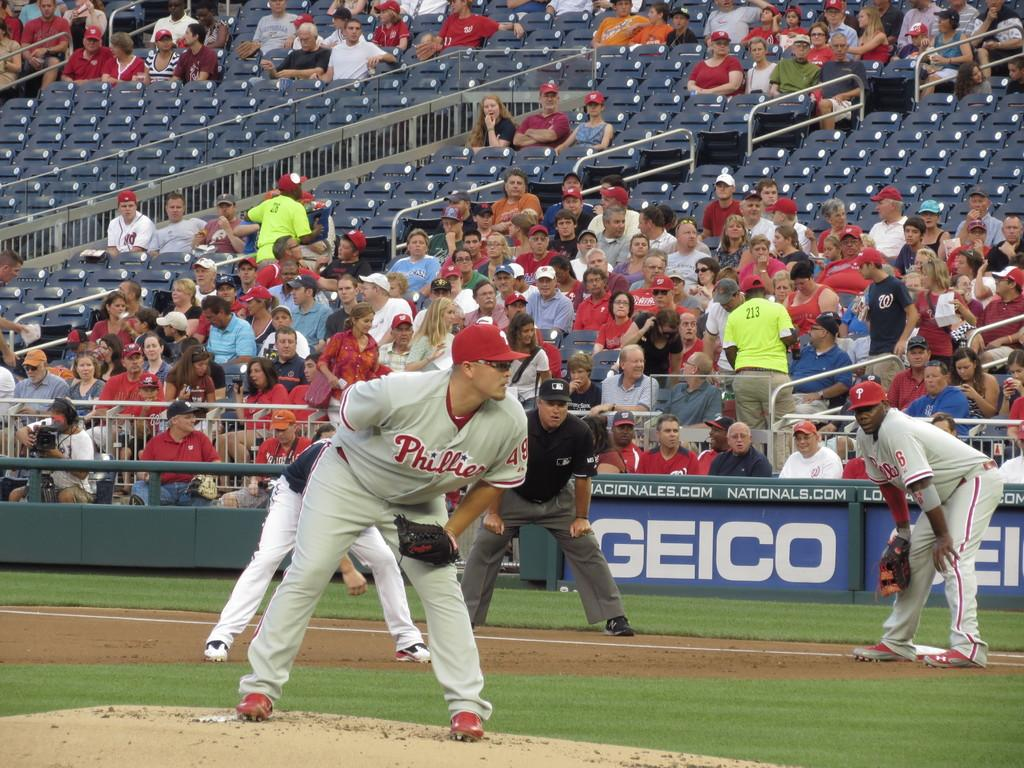<image>
Relay a brief, clear account of the picture shown. Baseball players playing a game with the company GEICO on a banner behind them. 